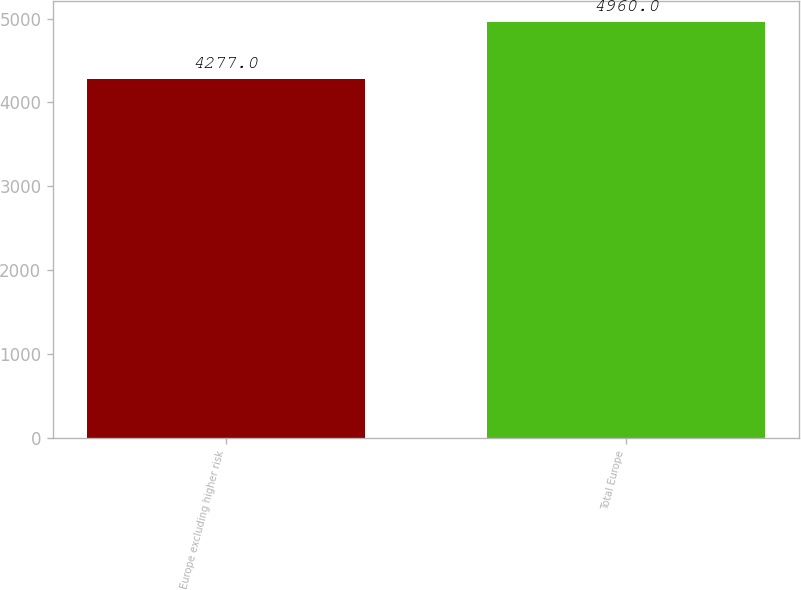<chart> <loc_0><loc_0><loc_500><loc_500><bar_chart><fcel>Europe excluding higher risk<fcel>Total Europe<nl><fcel>4277<fcel>4960<nl></chart> 